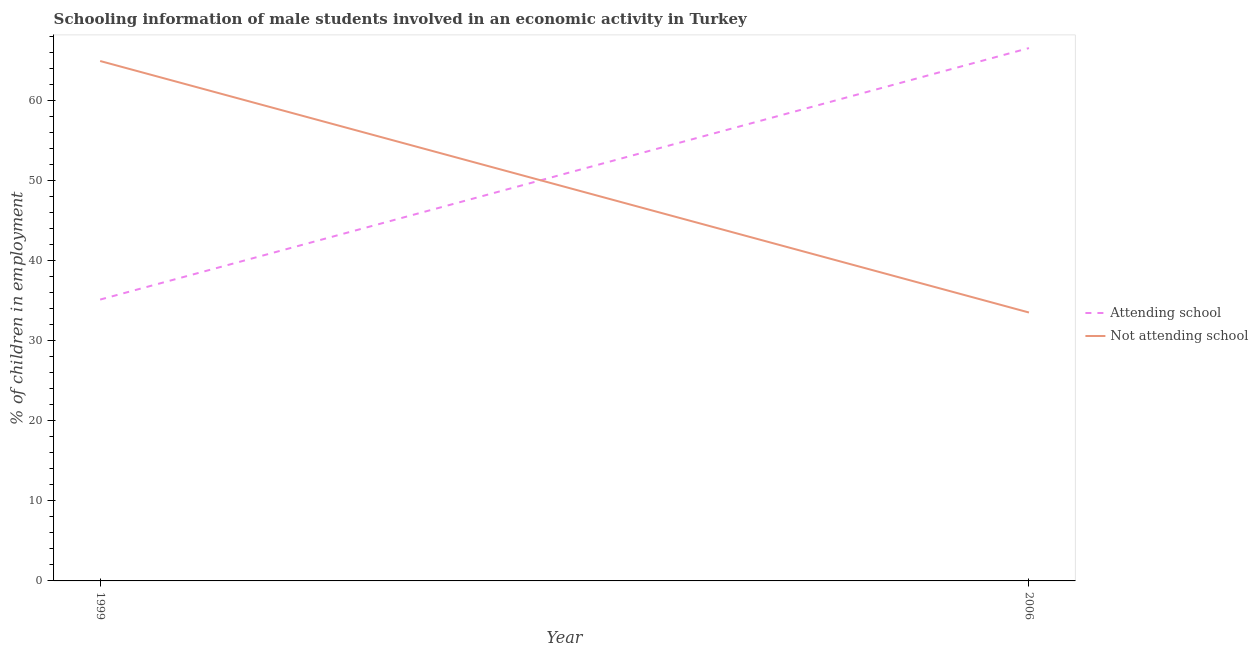How many different coloured lines are there?
Keep it short and to the point. 2. Does the line corresponding to percentage of employed males who are not attending school intersect with the line corresponding to percentage of employed males who are attending school?
Make the answer very short. Yes. Is the number of lines equal to the number of legend labels?
Make the answer very short. Yes. What is the percentage of employed males who are not attending school in 1999?
Offer a terse response. 64.89. Across all years, what is the maximum percentage of employed males who are attending school?
Make the answer very short. 66.5. Across all years, what is the minimum percentage of employed males who are attending school?
Provide a short and direct response. 35.11. In which year was the percentage of employed males who are attending school maximum?
Your answer should be very brief. 2006. What is the total percentage of employed males who are not attending school in the graph?
Your answer should be very brief. 98.39. What is the difference between the percentage of employed males who are not attending school in 1999 and that in 2006?
Give a very brief answer. 31.39. What is the difference between the percentage of employed males who are attending school in 2006 and the percentage of employed males who are not attending school in 1999?
Your answer should be compact. 1.61. What is the average percentage of employed males who are attending school per year?
Ensure brevity in your answer.  50.81. In the year 1999, what is the difference between the percentage of employed males who are not attending school and percentage of employed males who are attending school?
Your response must be concise. 29.77. What is the ratio of the percentage of employed males who are attending school in 1999 to that in 2006?
Your answer should be compact. 0.53. In how many years, is the percentage of employed males who are attending school greater than the average percentage of employed males who are attending school taken over all years?
Provide a succinct answer. 1. Is the percentage of employed males who are attending school strictly greater than the percentage of employed males who are not attending school over the years?
Your response must be concise. No. How many years are there in the graph?
Provide a succinct answer. 2. Are the values on the major ticks of Y-axis written in scientific E-notation?
Ensure brevity in your answer.  No. Does the graph contain any zero values?
Give a very brief answer. No. Does the graph contain grids?
Your answer should be very brief. No. Where does the legend appear in the graph?
Provide a succinct answer. Center right. How are the legend labels stacked?
Your response must be concise. Vertical. What is the title of the graph?
Offer a terse response. Schooling information of male students involved in an economic activity in Turkey. Does "RDB nonconcessional" appear as one of the legend labels in the graph?
Give a very brief answer. No. What is the label or title of the Y-axis?
Provide a succinct answer. % of children in employment. What is the % of children in employment in Attending school in 1999?
Your response must be concise. 35.11. What is the % of children in employment of Not attending school in 1999?
Make the answer very short. 64.89. What is the % of children in employment of Attending school in 2006?
Your answer should be compact. 66.5. What is the % of children in employment of Not attending school in 2006?
Your answer should be very brief. 33.5. Across all years, what is the maximum % of children in employment in Attending school?
Make the answer very short. 66.5. Across all years, what is the maximum % of children in employment of Not attending school?
Ensure brevity in your answer.  64.89. Across all years, what is the minimum % of children in employment of Attending school?
Offer a terse response. 35.11. Across all years, what is the minimum % of children in employment in Not attending school?
Ensure brevity in your answer.  33.5. What is the total % of children in employment of Attending school in the graph?
Make the answer very short. 101.61. What is the total % of children in employment of Not attending school in the graph?
Your answer should be very brief. 98.39. What is the difference between the % of children in employment of Attending school in 1999 and that in 2006?
Your response must be concise. -31.39. What is the difference between the % of children in employment in Not attending school in 1999 and that in 2006?
Provide a short and direct response. 31.39. What is the difference between the % of children in employment of Attending school in 1999 and the % of children in employment of Not attending school in 2006?
Your answer should be compact. 1.61. What is the average % of children in employment of Attending school per year?
Ensure brevity in your answer.  50.81. What is the average % of children in employment of Not attending school per year?
Keep it short and to the point. 49.19. In the year 1999, what is the difference between the % of children in employment of Attending school and % of children in employment of Not attending school?
Your answer should be compact. -29.77. What is the ratio of the % of children in employment of Attending school in 1999 to that in 2006?
Give a very brief answer. 0.53. What is the ratio of the % of children in employment in Not attending school in 1999 to that in 2006?
Provide a short and direct response. 1.94. What is the difference between the highest and the second highest % of children in employment in Attending school?
Provide a short and direct response. 31.39. What is the difference between the highest and the second highest % of children in employment of Not attending school?
Provide a succinct answer. 31.39. What is the difference between the highest and the lowest % of children in employment in Attending school?
Your response must be concise. 31.39. What is the difference between the highest and the lowest % of children in employment in Not attending school?
Provide a short and direct response. 31.39. 